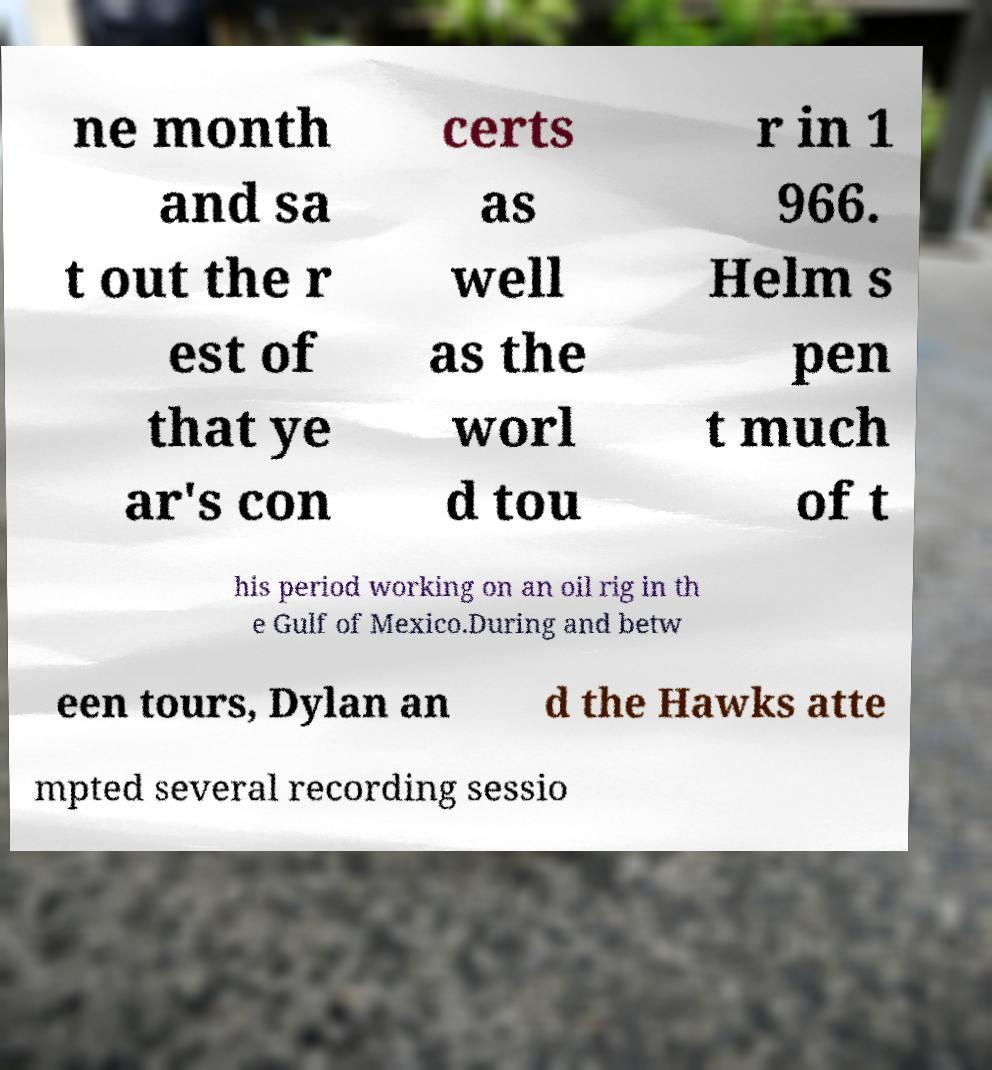Can you read and provide the text displayed in the image?This photo seems to have some interesting text. Can you extract and type it out for me? ne month and sa t out the r est of that ye ar's con certs as well as the worl d tou r in 1 966. Helm s pen t much of t his period working on an oil rig in th e Gulf of Mexico.During and betw een tours, Dylan an d the Hawks atte mpted several recording sessio 